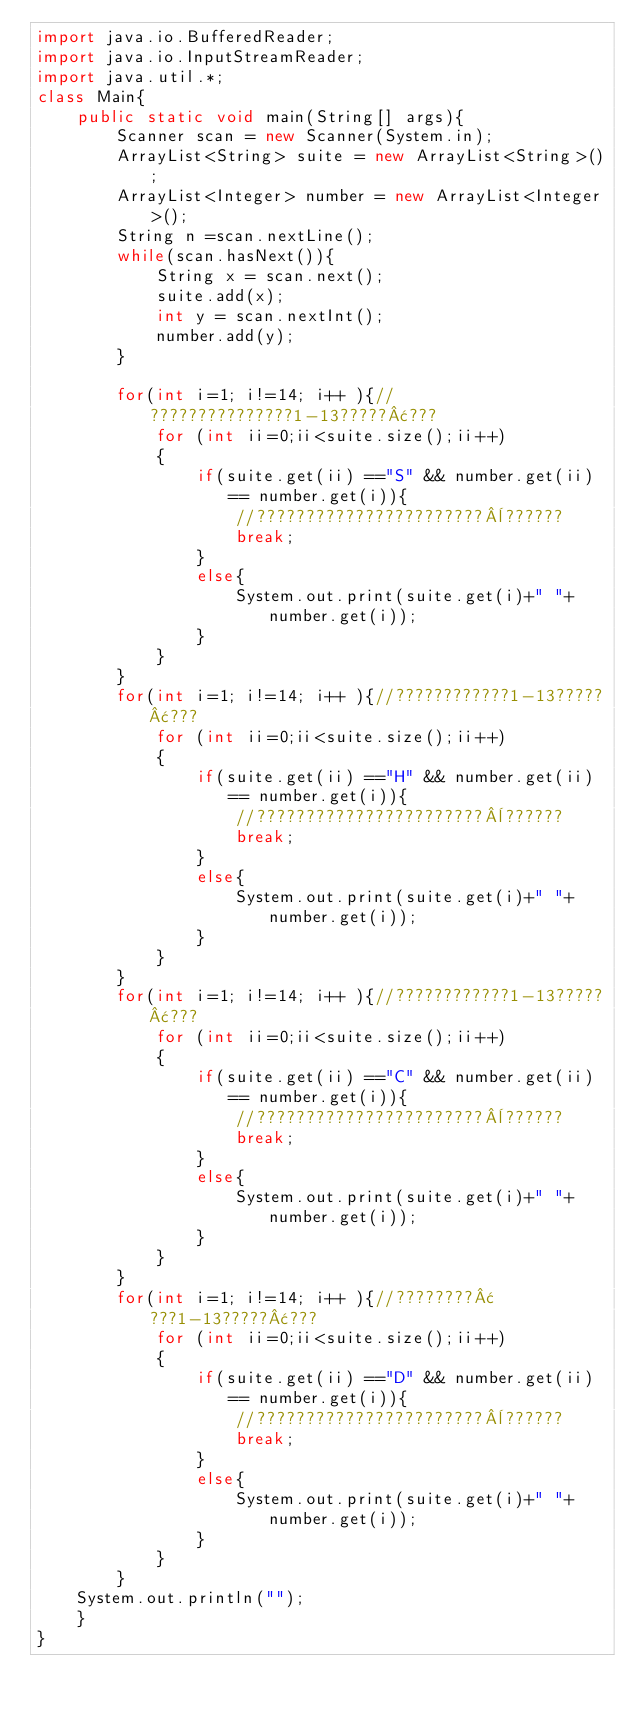Convert code to text. <code><loc_0><loc_0><loc_500><loc_500><_Java_>import java.io.BufferedReader;
import java.io.InputStreamReader;
import java.util.*;
class Main{
	public static void main(String[] args){
		Scanner scan = new Scanner(System.in);
		ArrayList<String> suite = new ArrayList<String>();
		ArrayList<Integer> number = new ArrayList<Integer>();
		String n =scan.nextLine();
		while(scan.hasNext()){
			String x = scan.next();
			suite.add(x);
			int y = scan.nextInt();
			number.add(y);
		}
		
		for(int i=1; i!=14; i++ ){//???????????????1-13?????¢???
			for (int ii=0;ii<suite.size();ii++)
			{
				if(suite.get(ii) =="S" && number.get(ii) == number.get(i)){
					//???????????????????????¨??????
					break;
				}
				else{
					System.out.print(suite.get(i)+" "+number.get(i));
				}
			}
		}
		for(int i=1; i!=14; i++ ){//????????????1-13?????¢???
			for (int ii=0;ii<suite.size();ii++)
			{
				if(suite.get(ii) =="H" && number.get(ii) == number.get(i)){
					//???????????????????????¨??????
					break;
				}
				else{
					System.out.print(suite.get(i)+" "+number.get(i));
				}
			}
		}
		for(int i=1; i!=14; i++ ){//????????????1-13?????¢???
			for (int ii=0;ii<suite.size();ii++)
			{
				if(suite.get(ii) =="C" && number.get(ii) == number.get(i)){
					//???????????????????????¨??????
					break;
				}
				else{
					System.out.print(suite.get(i)+" "+number.get(i));
				}
			}
		}
		for(int i=1; i!=14; i++ ){//????????¢???1-13?????¢???
			for (int ii=0;ii<suite.size();ii++)
			{
				if(suite.get(ii) =="D" && number.get(ii) == number.get(i)){
					//???????????????????????¨??????
					break;
				}
				else{
					System.out.print(suite.get(i)+" "+number.get(i));
				}
			}
		}
	System.out.println("");
	}
}</code> 